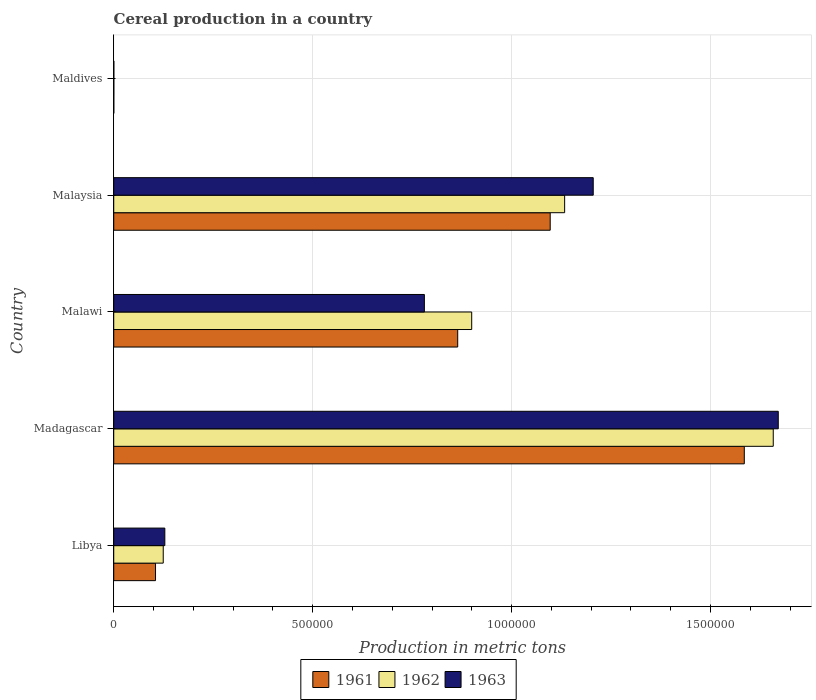How many different coloured bars are there?
Your answer should be compact. 3. Are the number of bars per tick equal to the number of legend labels?
Offer a terse response. Yes. Are the number of bars on each tick of the Y-axis equal?
Provide a succinct answer. Yes. What is the label of the 2nd group of bars from the top?
Provide a short and direct response. Malaysia. In how many cases, is the number of bars for a given country not equal to the number of legend labels?
Your response must be concise. 0. What is the total cereal production in 1963 in Malaysia?
Your answer should be compact. 1.21e+06. Across all countries, what is the maximum total cereal production in 1963?
Ensure brevity in your answer.  1.67e+06. Across all countries, what is the minimum total cereal production in 1962?
Your answer should be compact. 210. In which country was the total cereal production in 1963 maximum?
Make the answer very short. Madagascar. In which country was the total cereal production in 1962 minimum?
Your answer should be compact. Maldives. What is the total total cereal production in 1961 in the graph?
Offer a very short reply. 3.65e+06. What is the difference between the total cereal production in 1963 in Madagascar and that in Malawi?
Keep it short and to the point. 8.90e+05. What is the difference between the total cereal production in 1961 in Maldives and the total cereal production in 1963 in Madagascar?
Your response must be concise. -1.67e+06. What is the average total cereal production in 1962 per country?
Offer a terse response. 7.63e+05. What is the difference between the total cereal production in 1962 and total cereal production in 1961 in Madagascar?
Make the answer very short. 7.28e+04. What is the ratio of the total cereal production in 1961 in Libya to that in Maldives?
Keep it short and to the point. 660.33. Is the total cereal production in 1963 in Libya less than that in Malawi?
Keep it short and to the point. Yes. Is the difference between the total cereal production in 1962 in Libya and Maldives greater than the difference between the total cereal production in 1961 in Libya and Maldives?
Your response must be concise. Yes. What is the difference between the highest and the second highest total cereal production in 1962?
Your answer should be compact. 5.24e+05. What is the difference between the highest and the lowest total cereal production in 1961?
Provide a short and direct response. 1.58e+06. In how many countries, is the total cereal production in 1961 greater than the average total cereal production in 1961 taken over all countries?
Your answer should be compact. 3. What does the 1st bar from the top in Libya represents?
Your response must be concise. 1963. What does the 2nd bar from the bottom in Libya represents?
Keep it short and to the point. 1962. How many bars are there?
Your answer should be compact. 15. Are all the bars in the graph horizontal?
Ensure brevity in your answer.  Yes. Are the values on the major ticks of X-axis written in scientific E-notation?
Your response must be concise. No. How many legend labels are there?
Provide a short and direct response. 3. What is the title of the graph?
Your response must be concise. Cereal production in a country. What is the label or title of the X-axis?
Make the answer very short. Production in metric tons. What is the label or title of the Y-axis?
Your answer should be compact. Country. What is the Production in metric tons in 1961 in Libya?
Give a very brief answer. 1.05e+05. What is the Production in metric tons in 1962 in Libya?
Offer a very short reply. 1.24e+05. What is the Production in metric tons in 1963 in Libya?
Offer a very short reply. 1.28e+05. What is the Production in metric tons of 1961 in Madagascar?
Give a very brief answer. 1.58e+06. What is the Production in metric tons of 1962 in Madagascar?
Keep it short and to the point. 1.66e+06. What is the Production in metric tons in 1963 in Madagascar?
Ensure brevity in your answer.  1.67e+06. What is the Production in metric tons of 1961 in Malawi?
Provide a short and direct response. 8.65e+05. What is the Production in metric tons of 1962 in Malawi?
Make the answer very short. 9.00e+05. What is the Production in metric tons in 1963 in Malawi?
Offer a terse response. 7.81e+05. What is the Production in metric tons in 1961 in Malaysia?
Make the answer very short. 1.10e+06. What is the Production in metric tons in 1962 in Malaysia?
Ensure brevity in your answer.  1.13e+06. What is the Production in metric tons of 1963 in Malaysia?
Offer a terse response. 1.21e+06. What is the Production in metric tons of 1961 in Maldives?
Offer a terse response. 159. What is the Production in metric tons of 1962 in Maldives?
Provide a succinct answer. 210. What is the Production in metric tons of 1963 in Maldives?
Ensure brevity in your answer.  262. Across all countries, what is the maximum Production in metric tons of 1961?
Offer a very short reply. 1.58e+06. Across all countries, what is the maximum Production in metric tons of 1962?
Your answer should be compact. 1.66e+06. Across all countries, what is the maximum Production in metric tons in 1963?
Offer a very short reply. 1.67e+06. Across all countries, what is the minimum Production in metric tons in 1961?
Make the answer very short. 159. Across all countries, what is the minimum Production in metric tons of 1962?
Your answer should be very brief. 210. Across all countries, what is the minimum Production in metric tons in 1963?
Your answer should be compact. 262. What is the total Production in metric tons in 1961 in the graph?
Make the answer very short. 3.65e+06. What is the total Production in metric tons of 1962 in the graph?
Keep it short and to the point. 3.82e+06. What is the total Production in metric tons in 1963 in the graph?
Offer a terse response. 3.78e+06. What is the difference between the Production in metric tons in 1961 in Libya and that in Madagascar?
Your answer should be compact. -1.48e+06. What is the difference between the Production in metric tons in 1962 in Libya and that in Madagascar?
Ensure brevity in your answer.  -1.53e+06. What is the difference between the Production in metric tons of 1963 in Libya and that in Madagascar?
Your answer should be compact. -1.54e+06. What is the difference between the Production in metric tons of 1961 in Libya and that in Malawi?
Ensure brevity in your answer.  -7.60e+05. What is the difference between the Production in metric tons of 1962 in Libya and that in Malawi?
Keep it short and to the point. -7.75e+05. What is the difference between the Production in metric tons in 1963 in Libya and that in Malawi?
Make the answer very short. -6.52e+05. What is the difference between the Production in metric tons in 1961 in Libya and that in Malaysia?
Provide a succinct answer. -9.92e+05. What is the difference between the Production in metric tons of 1962 in Libya and that in Malaysia?
Your response must be concise. -1.01e+06. What is the difference between the Production in metric tons in 1963 in Libya and that in Malaysia?
Provide a succinct answer. -1.08e+06. What is the difference between the Production in metric tons of 1961 in Libya and that in Maldives?
Your answer should be very brief. 1.05e+05. What is the difference between the Production in metric tons of 1962 in Libya and that in Maldives?
Offer a terse response. 1.24e+05. What is the difference between the Production in metric tons in 1963 in Libya and that in Maldives?
Offer a terse response. 1.28e+05. What is the difference between the Production in metric tons in 1961 in Madagascar and that in Malawi?
Your answer should be very brief. 7.20e+05. What is the difference between the Production in metric tons of 1962 in Madagascar and that in Malawi?
Make the answer very short. 7.58e+05. What is the difference between the Production in metric tons of 1963 in Madagascar and that in Malawi?
Ensure brevity in your answer.  8.90e+05. What is the difference between the Production in metric tons of 1961 in Madagascar and that in Malaysia?
Provide a short and direct response. 4.88e+05. What is the difference between the Production in metric tons of 1962 in Madagascar and that in Malaysia?
Ensure brevity in your answer.  5.24e+05. What is the difference between the Production in metric tons in 1963 in Madagascar and that in Malaysia?
Provide a short and direct response. 4.65e+05. What is the difference between the Production in metric tons in 1961 in Madagascar and that in Maldives?
Give a very brief answer. 1.58e+06. What is the difference between the Production in metric tons in 1962 in Madagascar and that in Maldives?
Provide a short and direct response. 1.66e+06. What is the difference between the Production in metric tons in 1963 in Madagascar and that in Maldives?
Your answer should be very brief. 1.67e+06. What is the difference between the Production in metric tons in 1961 in Malawi and that in Malaysia?
Provide a short and direct response. -2.33e+05. What is the difference between the Production in metric tons of 1962 in Malawi and that in Malaysia?
Offer a terse response. -2.34e+05. What is the difference between the Production in metric tons of 1963 in Malawi and that in Malaysia?
Offer a very short reply. -4.24e+05. What is the difference between the Production in metric tons in 1961 in Malawi and that in Maldives?
Your response must be concise. 8.64e+05. What is the difference between the Production in metric tons in 1962 in Malawi and that in Maldives?
Provide a succinct answer. 9.00e+05. What is the difference between the Production in metric tons of 1963 in Malawi and that in Maldives?
Your response must be concise. 7.81e+05. What is the difference between the Production in metric tons of 1961 in Malaysia and that in Maldives?
Make the answer very short. 1.10e+06. What is the difference between the Production in metric tons in 1962 in Malaysia and that in Maldives?
Your response must be concise. 1.13e+06. What is the difference between the Production in metric tons of 1963 in Malaysia and that in Maldives?
Make the answer very short. 1.20e+06. What is the difference between the Production in metric tons of 1961 in Libya and the Production in metric tons of 1962 in Madagascar?
Offer a very short reply. -1.55e+06. What is the difference between the Production in metric tons of 1961 in Libya and the Production in metric tons of 1963 in Madagascar?
Your answer should be very brief. -1.57e+06. What is the difference between the Production in metric tons of 1962 in Libya and the Production in metric tons of 1963 in Madagascar?
Make the answer very short. -1.55e+06. What is the difference between the Production in metric tons of 1961 in Libya and the Production in metric tons of 1962 in Malawi?
Make the answer very short. -7.95e+05. What is the difference between the Production in metric tons of 1961 in Libya and the Production in metric tons of 1963 in Malawi?
Ensure brevity in your answer.  -6.76e+05. What is the difference between the Production in metric tons of 1962 in Libya and the Production in metric tons of 1963 in Malawi?
Provide a succinct answer. -6.56e+05. What is the difference between the Production in metric tons of 1961 in Libya and the Production in metric tons of 1962 in Malaysia?
Provide a short and direct response. -1.03e+06. What is the difference between the Production in metric tons in 1961 in Libya and the Production in metric tons in 1963 in Malaysia?
Your answer should be compact. -1.10e+06. What is the difference between the Production in metric tons of 1962 in Libya and the Production in metric tons of 1963 in Malaysia?
Offer a very short reply. -1.08e+06. What is the difference between the Production in metric tons of 1961 in Libya and the Production in metric tons of 1962 in Maldives?
Your answer should be very brief. 1.05e+05. What is the difference between the Production in metric tons of 1961 in Libya and the Production in metric tons of 1963 in Maldives?
Provide a short and direct response. 1.05e+05. What is the difference between the Production in metric tons of 1962 in Libya and the Production in metric tons of 1963 in Maldives?
Ensure brevity in your answer.  1.24e+05. What is the difference between the Production in metric tons in 1961 in Madagascar and the Production in metric tons in 1962 in Malawi?
Offer a terse response. 6.85e+05. What is the difference between the Production in metric tons in 1961 in Madagascar and the Production in metric tons in 1963 in Malawi?
Your answer should be compact. 8.04e+05. What is the difference between the Production in metric tons of 1962 in Madagascar and the Production in metric tons of 1963 in Malawi?
Keep it short and to the point. 8.77e+05. What is the difference between the Production in metric tons of 1961 in Madagascar and the Production in metric tons of 1962 in Malaysia?
Make the answer very short. 4.52e+05. What is the difference between the Production in metric tons in 1961 in Madagascar and the Production in metric tons in 1963 in Malaysia?
Provide a short and direct response. 3.80e+05. What is the difference between the Production in metric tons of 1962 in Madagascar and the Production in metric tons of 1963 in Malaysia?
Your answer should be compact. 4.52e+05. What is the difference between the Production in metric tons in 1961 in Madagascar and the Production in metric tons in 1962 in Maldives?
Offer a very short reply. 1.58e+06. What is the difference between the Production in metric tons in 1961 in Madagascar and the Production in metric tons in 1963 in Maldives?
Provide a succinct answer. 1.58e+06. What is the difference between the Production in metric tons in 1962 in Madagascar and the Production in metric tons in 1963 in Maldives?
Keep it short and to the point. 1.66e+06. What is the difference between the Production in metric tons in 1961 in Malawi and the Production in metric tons in 1962 in Malaysia?
Your answer should be very brief. -2.69e+05. What is the difference between the Production in metric tons of 1961 in Malawi and the Production in metric tons of 1963 in Malaysia?
Offer a very short reply. -3.41e+05. What is the difference between the Production in metric tons in 1962 in Malawi and the Production in metric tons in 1963 in Malaysia?
Offer a very short reply. -3.05e+05. What is the difference between the Production in metric tons of 1961 in Malawi and the Production in metric tons of 1962 in Maldives?
Ensure brevity in your answer.  8.64e+05. What is the difference between the Production in metric tons in 1961 in Malawi and the Production in metric tons in 1963 in Maldives?
Ensure brevity in your answer.  8.64e+05. What is the difference between the Production in metric tons in 1962 in Malawi and the Production in metric tons in 1963 in Maldives?
Your answer should be compact. 8.99e+05. What is the difference between the Production in metric tons of 1961 in Malaysia and the Production in metric tons of 1962 in Maldives?
Provide a short and direct response. 1.10e+06. What is the difference between the Production in metric tons of 1961 in Malaysia and the Production in metric tons of 1963 in Maldives?
Offer a terse response. 1.10e+06. What is the difference between the Production in metric tons of 1962 in Malaysia and the Production in metric tons of 1963 in Maldives?
Offer a terse response. 1.13e+06. What is the average Production in metric tons in 1961 per country?
Your response must be concise. 7.30e+05. What is the average Production in metric tons of 1962 per country?
Keep it short and to the point. 7.63e+05. What is the average Production in metric tons in 1963 per country?
Ensure brevity in your answer.  7.57e+05. What is the difference between the Production in metric tons in 1961 and Production in metric tons in 1962 in Libya?
Give a very brief answer. -1.94e+04. What is the difference between the Production in metric tons in 1961 and Production in metric tons in 1963 in Libya?
Make the answer very short. -2.34e+04. What is the difference between the Production in metric tons of 1962 and Production in metric tons of 1963 in Libya?
Your response must be concise. -4000. What is the difference between the Production in metric tons in 1961 and Production in metric tons in 1962 in Madagascar?
Your response must be concise. -7.28e+04. What is the difference between the Production in metric tons of 1961 and Production in metric tons of 1963 in Madagascar?
Make the answer very short. -8.54e+04. What is the difference between the Production in metric tons in 1962 and Production in metric tons in 1963 in Madagascar?
Your response must be concise. -1.26e+04. What is the difference between the Production in metric tons in 1961 and Production in metric tons in 1962 in Malawi?
Offer a very short reply. -3.52e+04. What is the difference between the Production in metric tons in 1961 and Production in metric tons in 1963 in Malawi?
Provide a succinct answer. 8.38e+04. What is the difference between the Production in metric tons of 1962 and Production in metric tons of 1963 in Malawi?
Provide a short and direct response. 1.19e+05. What is the difference between the Production in metric tons of 1961 and Production in metric tons of 1962 in Malaysia?
Give a very brief answer. -3.63e+04. What is the difference between the Production in metric tons in 1961 and Production in metric tons in 1963 in Malaysia?
Keep it short and to the point. -1.08e+05. What is the difference between the Production in metric tons of 1962 and Production in metric tons of 1963 in Malaysia?
Ensure brevity in your answer.  -7.19e+04. What is the difference between the Production in metric tons in 1961 and Production in metric tons in 1962 in Maldives?
Make the answer very short. -51. What is the difference between the Production in metric tons in 1961 and Production in metric tons in 1963 in Maldives?
Provide a succinct answer. -103. What is the difference between the Production in metric tons in 1962 and Production in metric tons in 1963 in Maldives?
Your response must be concise. -52. What is the ratio of the Production in metric tons of 1961 in Libya to that in Madagascar?
Offer a terse response. 0.07. What is the ratio of the Production in metric tons of 1962 in Libya to that in Madagascar?
Offer a very short reply. 0.07. What is the ratio of the Production in metric tons in 1963 in Libya to that in Madagascar?
Your answer should be compact. 0.08. What is the ratio of the Production in metric tons in 1961 in Libya to that in Malawi?
Offer a terse response. 0.12. What is the ratio of the Production in metric tons in 1962 in Libya to that in Malawi?
Ensure brevity in your answer.  0.14. What is the ratio of the Production in metric tons in 1963 in Libya to that in Malawi?
Offer a terse response. 0.16. What is the ratio of the Production in metric tons in 1961 in Libya to that in Malaysia?
Provide a short and direct response. 0.1. What is the ratio of the Production in metric tons in 1962 in Libya to that in Malaysia?
Offer a very short reply. 0.11. What is the ratio of the Production in metric tons of 1963 in Libya to that in Malaysia?
Make the answer very short. 0.11. What is the ratio of the Production in metric tons in 1961 in Libya to that in Maldives?
Your answer should be compact. 660.33. What is the ratio of the Production in metric tons of 1962 in Libya to that in Maldives?
Your answer should be compact. 592.38. What is the ratio of the Production in metric tons of 1963 in Libya to that in Maldives?
Give a very brief answer. 490.08. What is the ratio of the Production in metric tons of 1961 in Madagascar to that in Malawi?
Make the answer very short. 1.83. What is the ratio of the Production in metric tons of 1962 in Madagascar to that in Malawi?
Provide a succinct answer. 1.84. What is the ratio of the Production in metric tons of 1963 in Madagascar to that in Malawi?
Give a very brief answer. 2.14. What is the ratio of the Production in metric tons of 1961 in Madagascar to that in Malaysia?
Provide a short and direct response. 1.44. What is the ratio of the Production in metric tons in 1962 in Madagascar to that in Malaysia?
Offer a very short reply. 1.46. What is the ratio of the Production in metric tons of 1963 in Madagascar to that in Malaysia?
Provide a short and direct response. 1.39. What is the ratio of the Production in metric tons of 1961 in Madagascar to that in Maldives?
Keep it short and to the point. 9968.05. What is the ratio of the Production in metric tons in 1962 in Madagascar to that in Maldives?
Your answer should be very brief. 7893.81. What is the ratio of the Production in metric tons in 1963 in Madagascar to that in Maldives?
Provide a short and direct response. 6375.19. What is the ratio of the Production in metric tons in 1961 in Malawi to that in Malaysia?
Offer a very short reply. 0.79. What is the ratio of the Production in metric tons in 1962 in Malawi to that in Malaysia?
Your answer should be compact. 0.79. What is the ratio of the Production in metric tons in 1963 in Malawi to that in Malaysia?
Provide a succinct answer. 0.65. What is the ratio of the Production in metric tons of 1961 in Malawi to that in Maldives?
Your response must be concise. 5437.45. What is the ratio of the Production in metric tons in 1962 in Malawi to that in Maldives?
Provide a short and direct response. 4284.53. What is the ratio of the Production in metric tons of 1963 in Malawi to that in Maldives?
Make the answer very short. 2980.08. What is the ratio of the Production in metric tons of 1961 in Malaysia to that in Maldives?
Offer a very short reply. 6899.84. What is the ratio of the Production in metric tons of 1962 in Malaysia to that in Maldives?
Ensure brevity in your answer.  5396.87. What is the ratio of the Production in metric tons in 1963 in Malaysia to that in Maldives?
Your answer should be very brief. 4600.05. What is the difference between the highest and the second highest Production in metric tons of 1961?
Ensure brevity in your answer.  4.88e+05. What is the difference between the highest and the second highest Production in metric tons of 1962?
Provide a succinct answer. 5.24e+05. What is the difference between the highest and the second highest Production in metric tons of 1963?
Keep it short and to the point. 4.65e+05. What is the difference between the highest and the lowest Production in metric tons in 1961?
Give a very brief answer. 1.58e+06. What is the difference between the highest and the lowest Production in metric tons in 1962?
Ensure brevity in your answer.  1.66e+06. What is the difference between the highest and the lowest Production in metric tons in 1963?
Offer a terse response. 1.67e+06. 